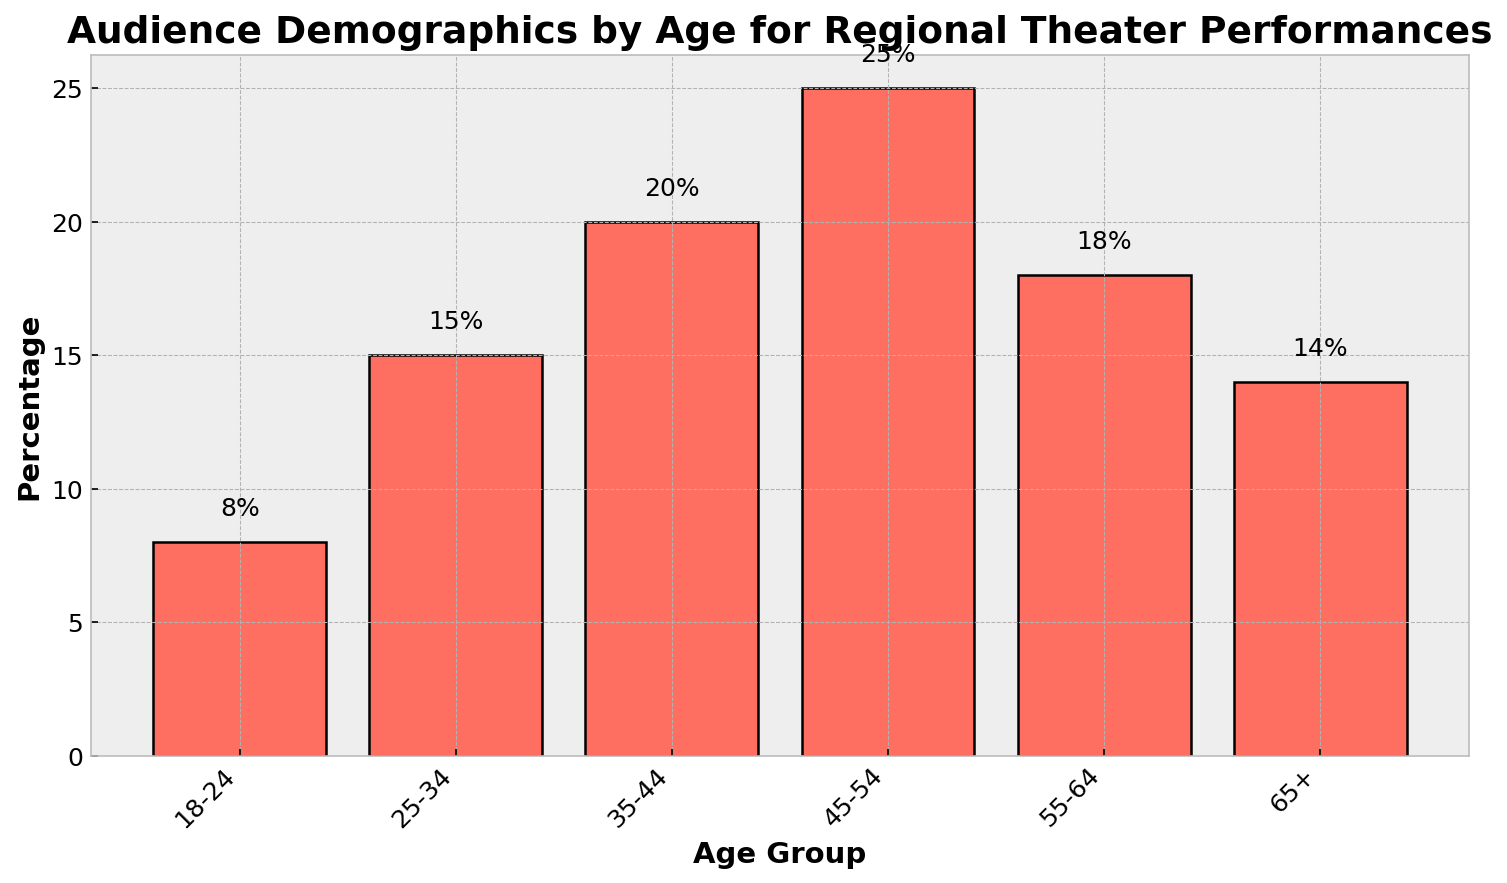What is the age group with the highest audience percentage? The figure shows that the bar representing the age group 45-54 is the tallest, indicating it has the highest percentage of the audience.
Answer: 45-54 Which age group has the lowest percentage of audience members? The figure indicates that the shortest bar belongs to the age group 18-24, showing the smallest percentage of audience members.
Answer: 18-24 How many age groups have a percentage of audience members greater than 20%? By observing the heights of the bars, only one age group exceeds 20%: the 45-54 age group with 25%.
Answer: 1 What is the total percentage of audience members aged 35 and above? By summing the percentages: 20% (35-44) + 25% (45-54) + 18% (55-64) + 14% (65+) = 77%.
Answer: 77% What is the difference in audience percentage between the 25-34 and 55-64 age groups? The figure shows the 25-34 age group at 15% and the 55-64 age group at 18%. The difference is 18% - 15% = 3%.
Answer: 3% Which two adjacent age groups have the smallest difference in percentage? Calculate differences between adjacent age groups: (25-34)-(18-24) = 7%, (35-44)-(25-34) = 5%, (45-54)-(35-44) = 5%, (55-64)-(45-54) = -7%, (65+)-(55-64) = -4%. The smallest positive difference is between 35-44 and 25-34.
Answer: 25-34 and 35-44 Compare the combined percentage of the youngest and oldest age groups against 25-34. Which is higher? Sum percentages: 18-24 (8%) + 65+ (14%) = 22%. Since the 25-34 age group is 15%, 22% is higher than 15%.
Answer: Youngest and oldest What is the average percentage of audience members across all age groups? Add up all percentages and divide by the number of age groups: (8% + 15% + 20% + 25% + 18% + 14%) / 6 = 16.67%.
Answer: 16.67% What is the median percentage of all age groups? Arrange percentages in ascending order: 8%, 14%, 15%, 18%, 20%, 25%. The median for 6 numbers is the average of the 3rd and 4th values: (15% + 18%) / 2 = 16.5%.
Answer: 16.5% Does any age group have a percentage exactly 20%? By looking at the height of the bars, the age group 35-44 has exactly 20%.
Answer: Yes 